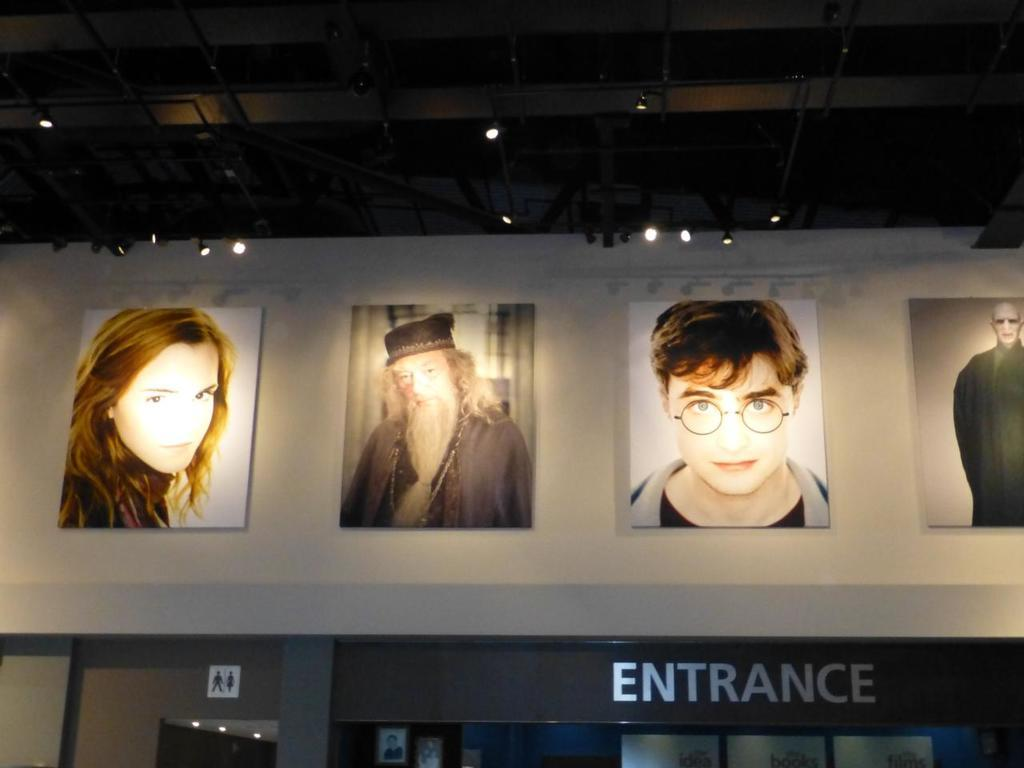What can be seen hanging on the wall in the image? There are photos on the wall in the image. What object in the image might be used for identifying a person or place? There is a name board in the image. What other type of board is present in the image? There is a sign board in the image. What is visible at the top of the image? Lights are visible at the top of the image. Can you see a boat at the edge of the image? There is no boat present in the image, and the concept of an "edge" is not applicable to this image. 